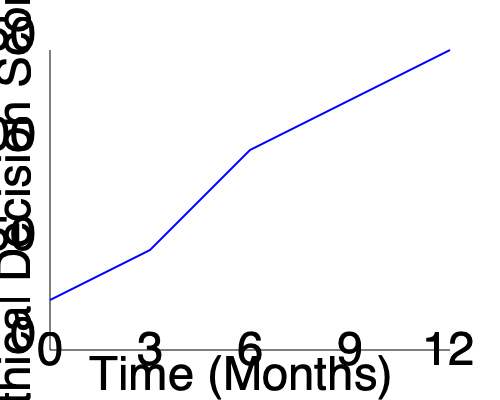As a local business owner who values ethical decision-making, analyze the line graph depicting ethical decision-making scenarios over a 12-month period. What is the average rate of increase in the Ethical Decision Score per month? To solve this problem, we need to follow these steps:

1. Identify the starting and ending points of the graph:
   - Start: (0 months, 0 score)
   - End: (12 months, 150 score)

2. Calculate the total change in Ethical Decision Score:
   $\Delta Score = 150 - 0 = 150$

3. Calculate the total time period:
   $\Delta Time = 12 - 0 = 12$ months

4. Use the formula for average rate of increase:
   $\text{Average rate} = \frac{\text{Total change}}{\text{Time period}}$

5. Plug in the values:
   $\text{Average rate} = \frac{150}{12} = 12.5$

Therefore, the average rate of increase in the Ethical Decision Score is 12.5 points per month.
Answer: 12.5 points per month 